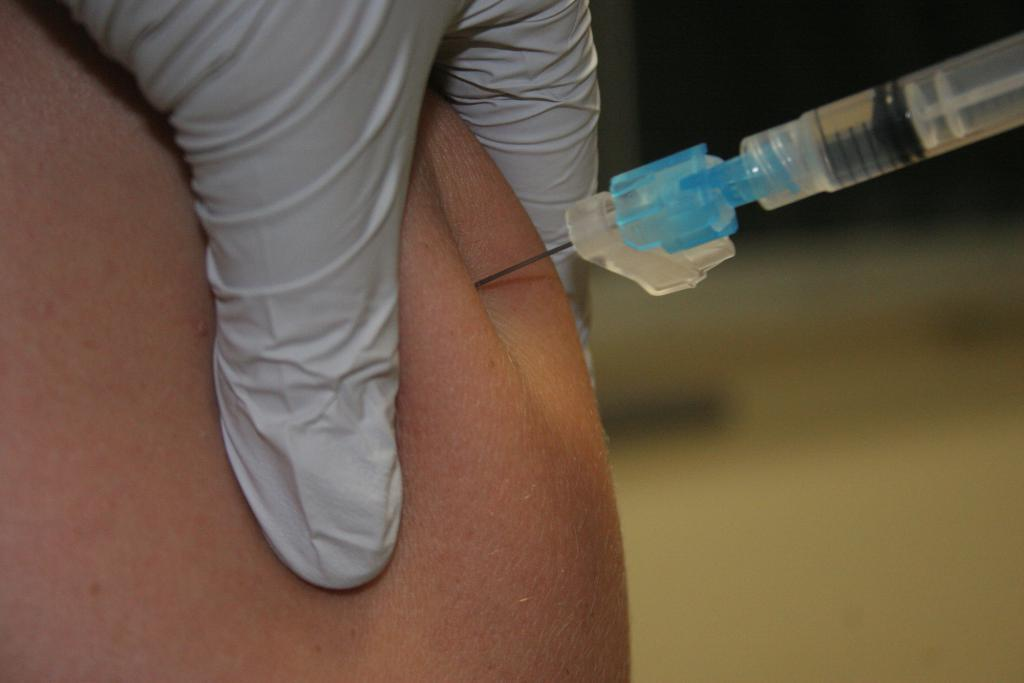What is the main focus in the foreground of the image? There is a person's hand in the foreground of the image. What is being held by the hand in the image? There is an injection needle in the image. What is the position of the injection needle in relation to the human's body? The injection needle is in the human's skin. How would you describe the background of the image? The background of the image is blurred. What type of badge is pinned to the person's nose in the image? There is no badge or nose present in the image; it only features a person's hand and an injection needle. What kind of loaf is being used to hold the injection needle in the image? There is no loaf present in the image; the injection needle is held by a person's hand. 